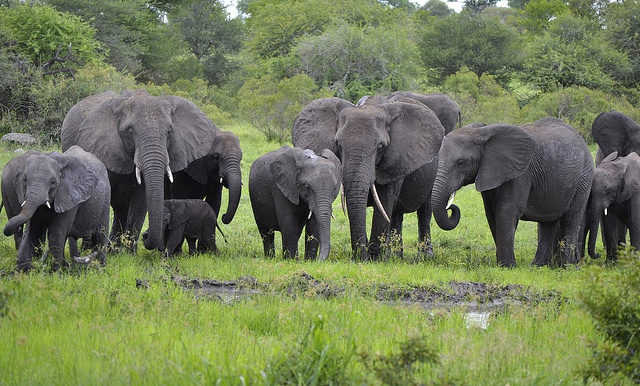Describe the objects in this image and their specific colors. I can see elephant in gray and black tones, elephant in gray and black tones, elephant in gray and black tones, elephant in gray, black, and darkgray tones, and elephant in gray, black, and darkgray tones in this image. 